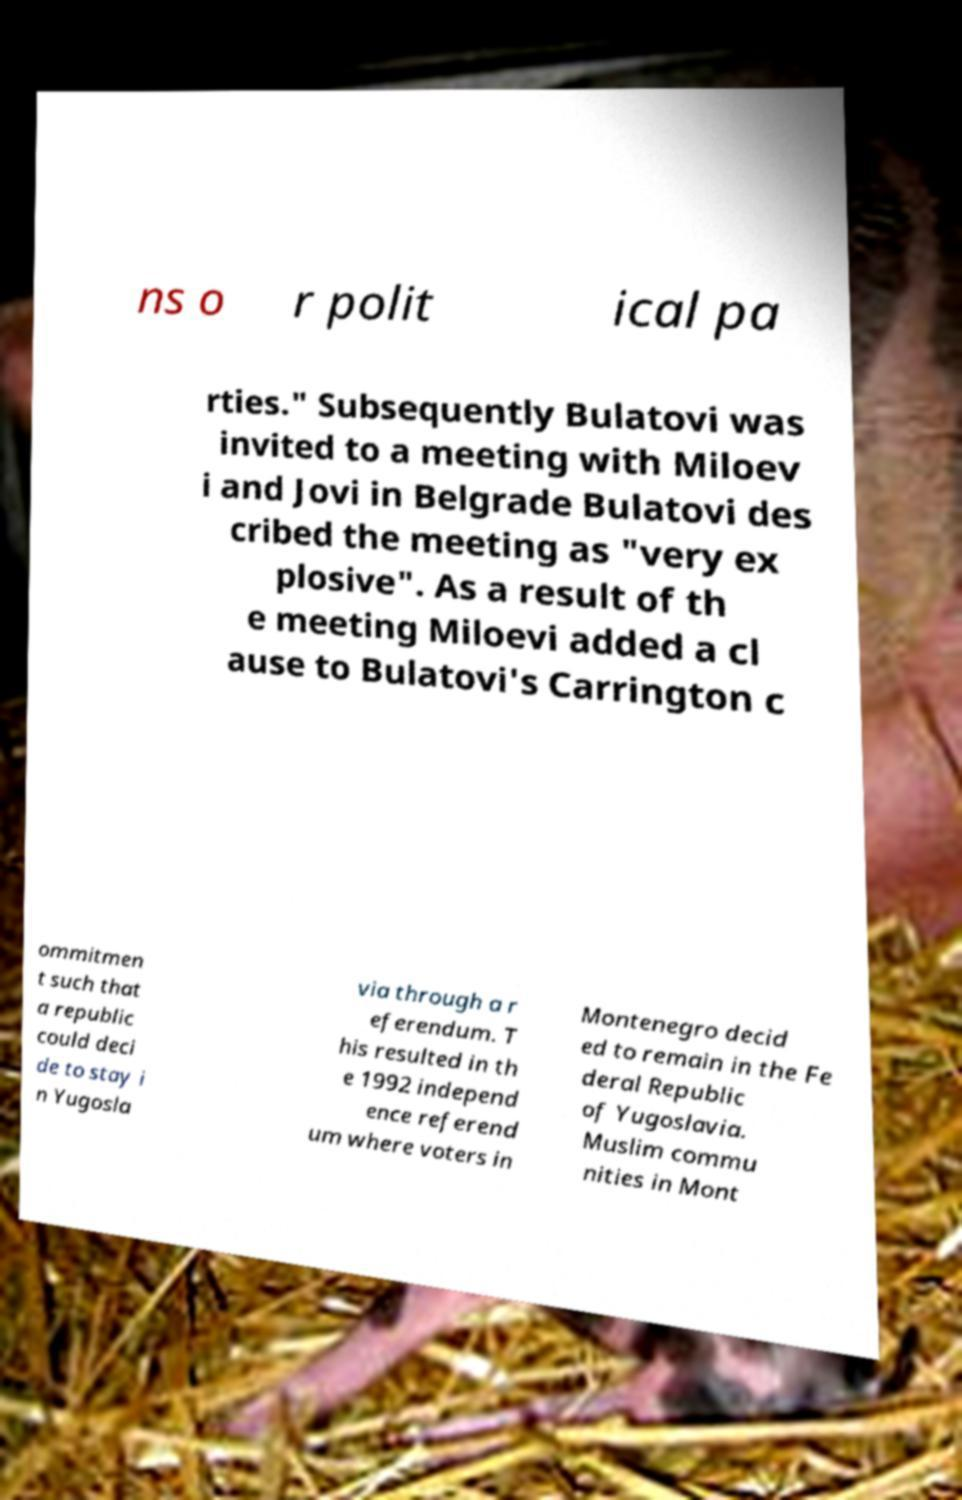What messages or text are displayed in this image? I need them in a readable, typed format. ns o r polit ical pa rties." Subsequently Bulatovi was invited to a meeting with Miloev i and Jovi in Belgrade Bulatovi des cribed the meeting as "very ex plosive". As a result of th e meeting Miloevi added a cl ause to Bulatovi's Carrington c ommitmen t such that a republic could deci de to stay i n Yugosla via through a r eferendum. T his resulted in th e 1992 independ ence referend um where voters in Montenegro decid ed to remain in the Fe deral Republic of Yugoslavia. Muslim commu nities in Mont 